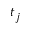Convert formula to latex. <formula><loc_0><loc_0><loc_500><loc_500>t _ { j }</formula> 